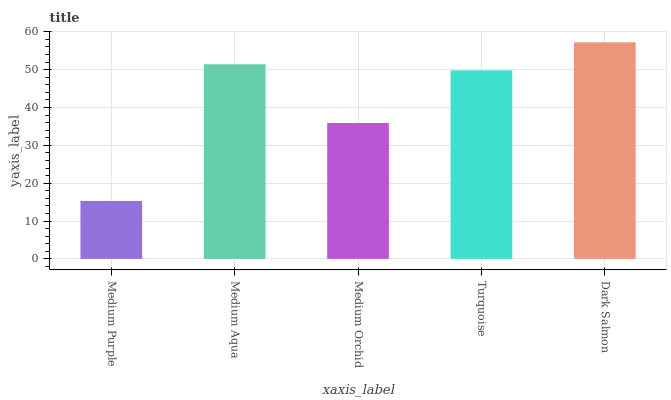Is Medium Purple the minimum?
Answer yes or no. Yes. Is Dark Salmon the maximum?
Answer yes or no. Yes. Is Medium Aqua the minimum?
Answer yes or no. No. Is Medium Aqua the maximum?
Answer yes or no. No. Is Medium Aqua greater than Medium Purple?
Answer yes or no. Yes. Is Medium Purple less than Medium Aqua?
Answer yes or no. Yes. Is Medium Purple greater than Medium Aqua?
Answer yes or no. No. Is Medium Aqua less than Medium Purple?
Answer yes or no. No. Is Turquoise the high median?
Answer yes or no. Yes. Is Turquoise the low median?
Answer yes or no. Yes. Is Medium Aqua the high median?
Answer yes or no. No. Is Dark Salmon the low median?
Answer yes or no. No. 